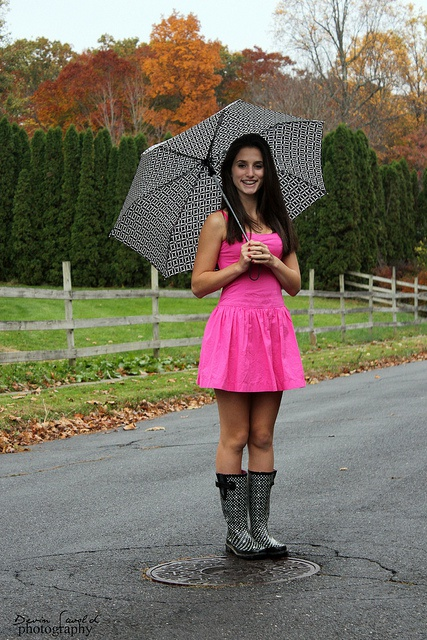Describe the objects in this image and their specific colors. I can see people in gray, black, violet, and maroon tones and umbrella in gray, black, darkgray, and lightgray tones in this image. 